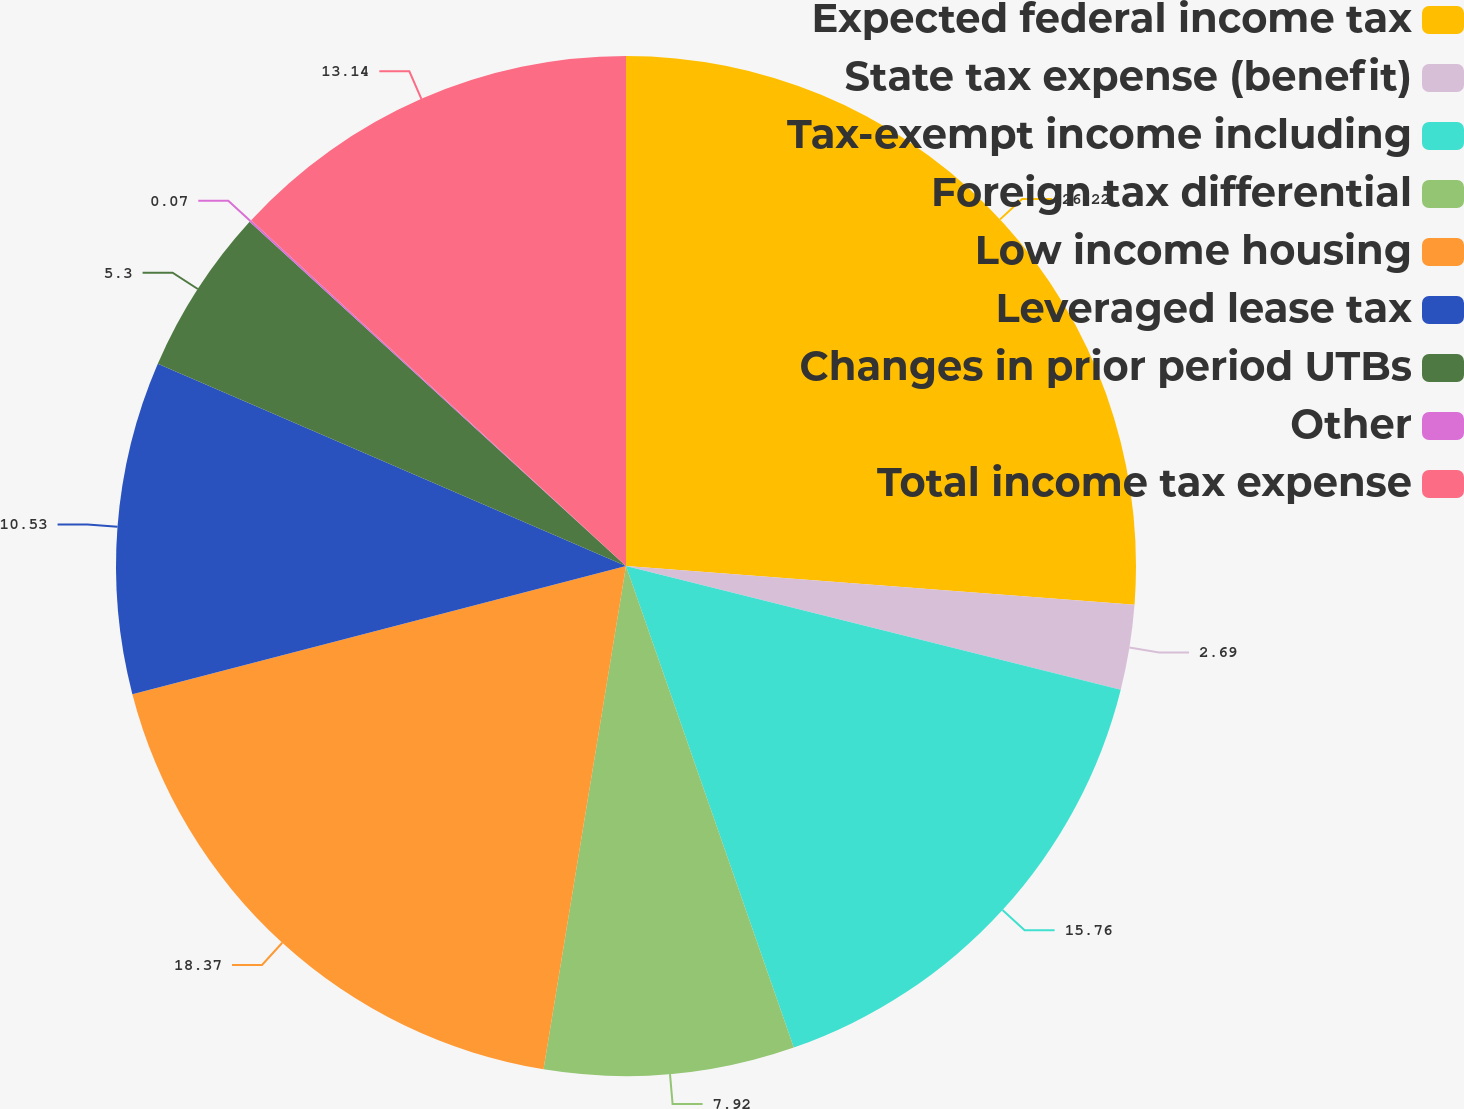Convert chart. <chart><loc_0><loc_0><loc_500><loc_500><pie_chart><fcel>Expected federal income tax<fcel>State tax expense (benefit)<fcel>Tax-exempt income including<fcel>Foreign tax differential<fcel>Low income housing<fcel>Leveraged lease tax<fcel>Changes in prior period UTBs<fcel>Other<fcel>Total income tax expense<nl><fcel>26.21%<fcel>2.69%<fcel>15.76%<fcel>7.92%<fcel>18.37%<fcel>10.53%<fcel>5.3%<fcel>0.07%<fcel>13.14%<nl></chart> 